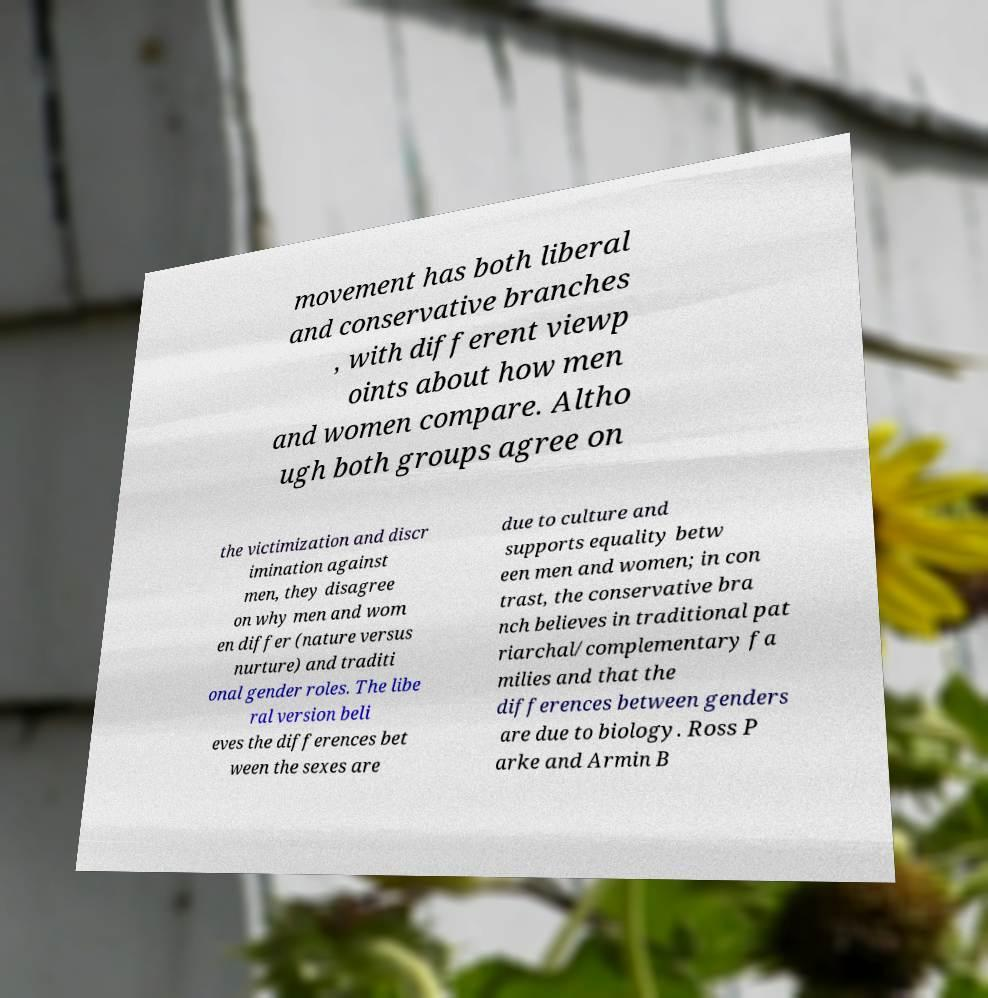Please read and relay the text visible in this image. What does it say? movement has both liberal and conservative branches , with different viewp oints about how men and women compare. Altho ugh both groups agree on the victimization and discr imination against men, they disagree on why men and wom en differ (nature versus nurture) and traditi onal gender roles. The libe ral version beli eves the differences bet ween the sexes are due to culture and supports equality betw een men and women; in con trast, the conservative bra nch believes in traditional pat riarchal/complementary fa milies and that the differences between genders are due to biology. Ross P arke and Armin B 